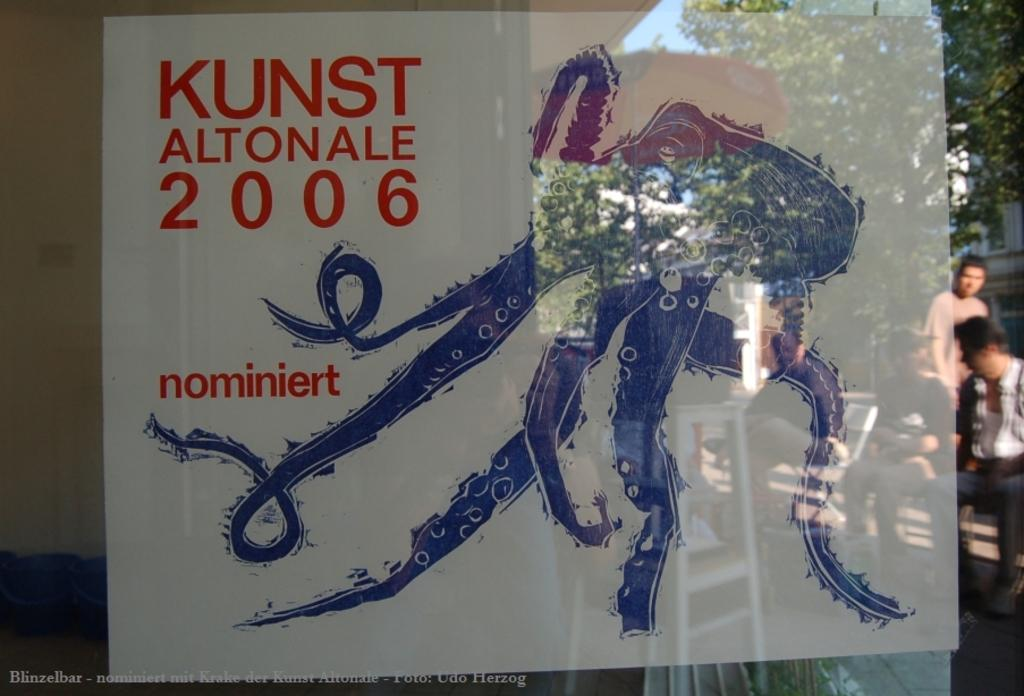Provide a one-sentence caption for the provided image. An octopus with the caption Kunst altonale 2006. 